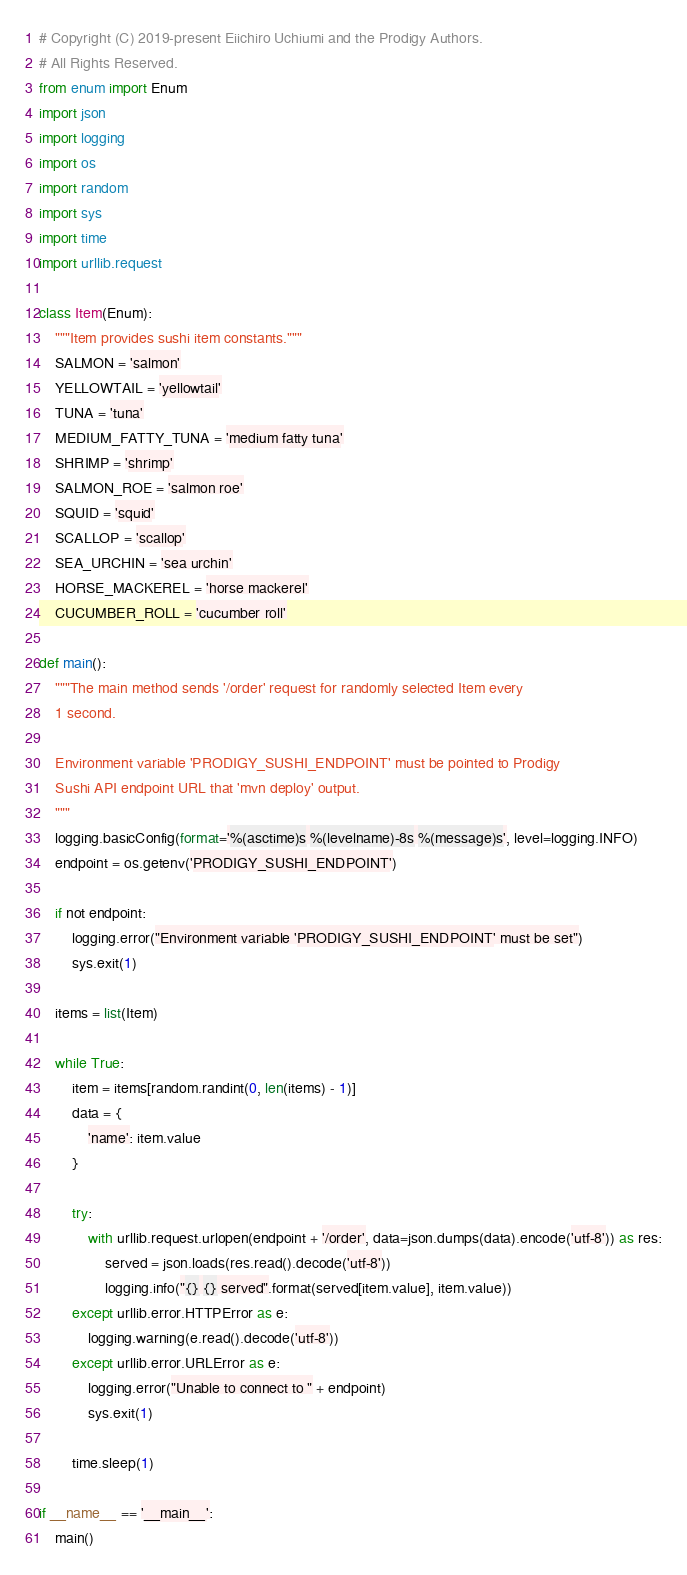Convert code to text. <code><loc_0><loc_0><loc_500><loc_500><_Python_># Copyright (C) 2019-present Eiichiro Uchiumi and the Prodigy Authors. 
# All Rights Reserved.
from enum import Enum
import json
import logging
import os
import random
import sys
import time
import urllib.request

class Item(Enum):
    """Item provides sushi item constants."""
    SALMON = 'salmon'
    YELLOWTAIL = 'yellowtail'
    TUNA = 'tuna'
    MEDIUM_FATTY_TUNA = 'medium fatty tuna'
    SHRIMP = 'shrimp'
    SALMON_ROE = 'salmon roe'
    SQUID = 'squid'
    SCALLOP = 'scallop'
    SEA_URCHIN = 'sea urchin'
    HORSE_MACKEREL = 'horse mackerel'
    CUCUMBER_ROLL = 'cucumber roll'

def main():
    """The main method sends '/order' request for randomly selected Item every 
    1 second.

    Environment variable 'PRODIGY_SUSHI_ENDPOINT' must be pointed to Prodigy 
    Sushi API endpoint URL that 'mvn deploy' output.
    """
    logging.basicConfig(format='%(asctime)s %(levelname)-8s %(message)s', level=logging.INFO)
    endpoint = os.getenv('PRODIGY_SUSHI_ENDPOINT')
    
    if not endpoint:
        logging.error("Environment variable 'PRODIGY_SUSHI_ENDPOINT' must be set")
        sys.exit(1)
    
    items = list(Item)
    
    while True:
        item = items[random.randint(0, len(items) - 1)]
        data = {
            'name': item.value
        }

        try: 
            with urllib.request.urlopen(endpoint + '/order', data=json.dumps(data).encode('utf-8')) as res:
                served = json.loads(res.read().decode('utf-8'))
                logging.info("{} {} served".format(served[item.value], item.value))
        except urllib.error.HTTPError as e:
            logging.warning(e.read().decode('utf-8'))
        except urllib.error.URLError as e:
            logging.error("Unable to connect to " + endpoint)
            sys.exit(1)
        
        time.sleep(1)
        
if __name__ == '__main__':
    main()
</code> 